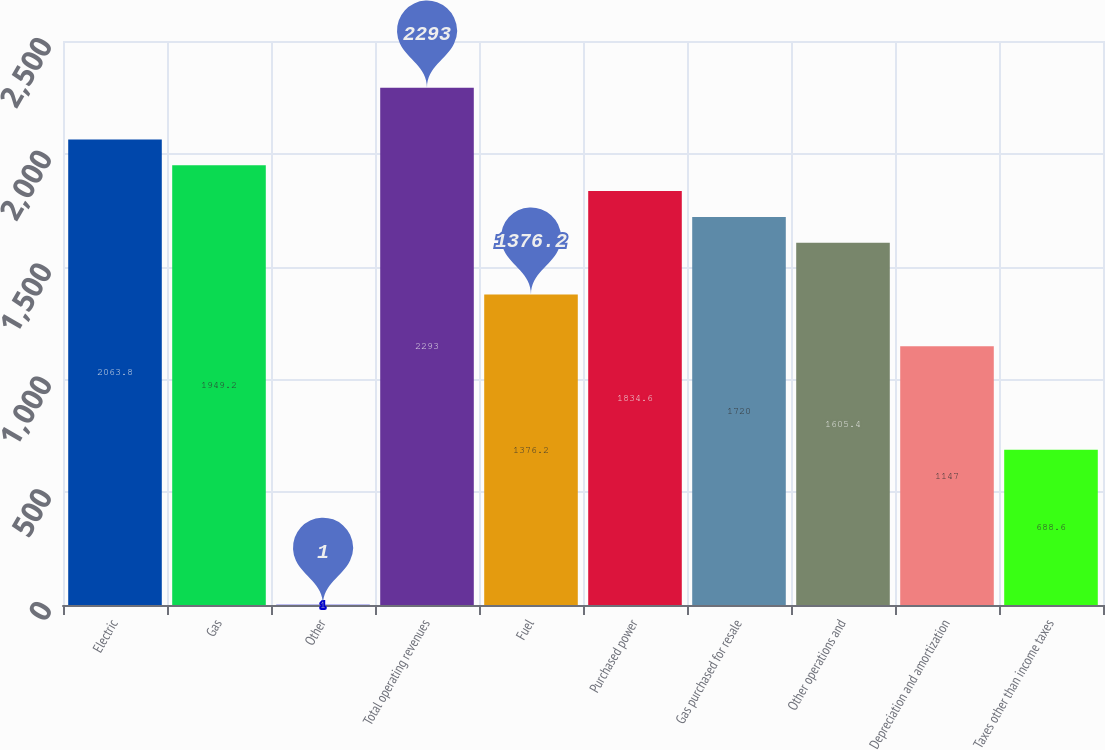Convert chart to OTSL. <chart><loc_0><loc_0><loc_500><loc_500><bar_chart><fcel>Electric<fcel>Gas<fcel>Other<fcel>Total operating revenues<fcel>Fuel<fcel>Purchased power<fcel>Gas purchased for resale<fcel>Other operations and<fcel>Depreciation and amortization<fcel>Taxes other than income taxes<nl><fcel>2063.8<fcel>1949.2<fcel>1<fcel>2293<fcel>1376.2<fcel>1834.6<fcel>1720<fcel>1605.4<fcel>1147<fcel>688.6<nl></chart> 